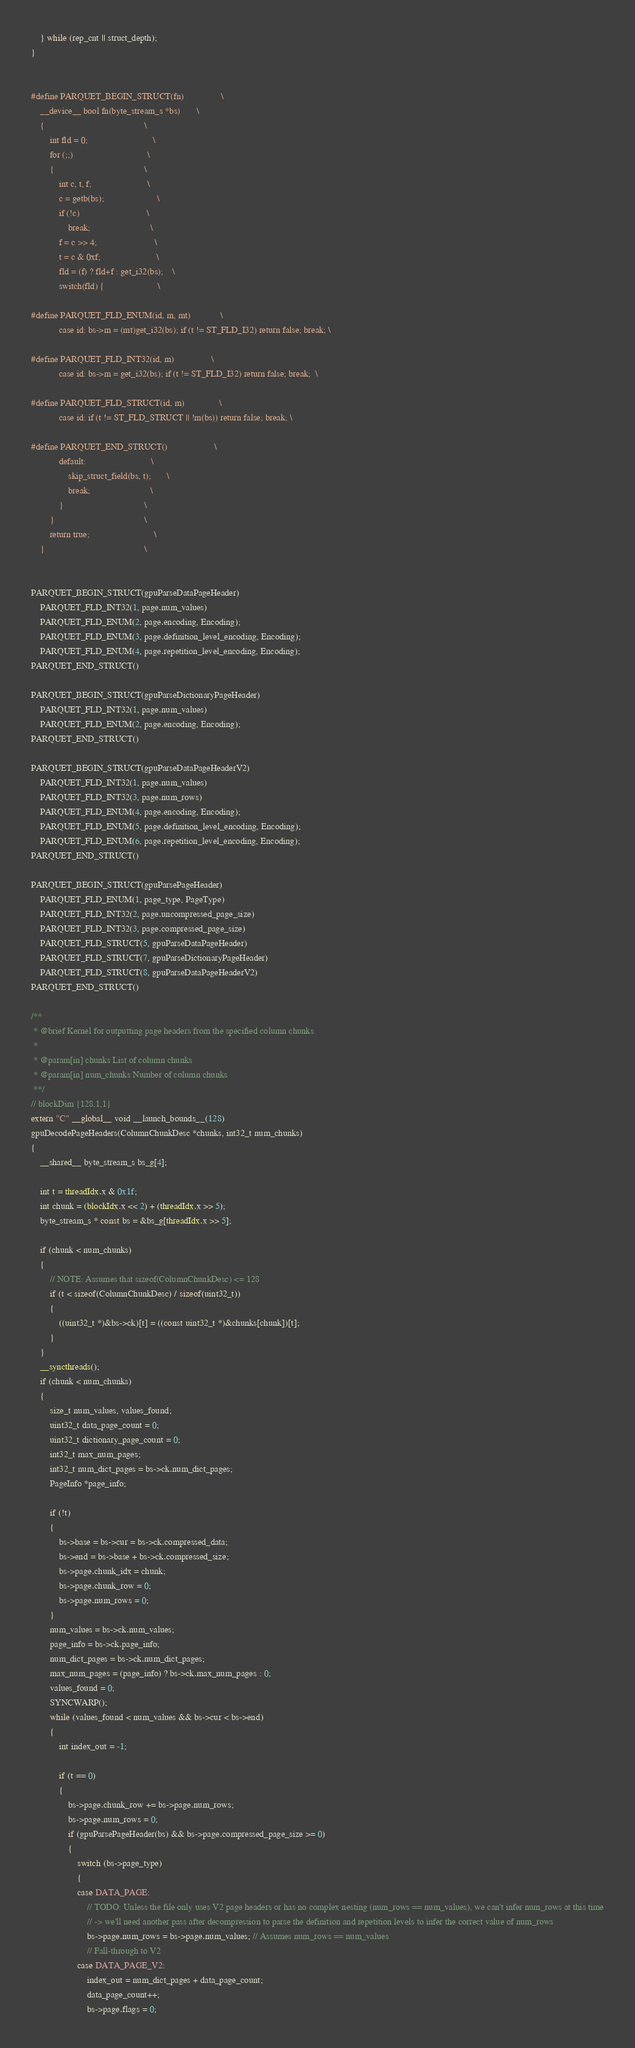<code> <loc_0><loc_0><loc_500><loc_500><_Cuda_>    } while (rep_cnt || struct_depth);
}


#define PARQUET_BEGIN_STRUCT(fn)                \
    __device__ bool fn(byte_stream_s *bs)       \
    {                                           \
        int fld = 0;                            \
        for (;;)                                \
        {                                       \
            int c, t, f;                        \
            c = getb(bs);                       \
            if (!c)                             \
                break;                          \
            f = c >> 4;                         \
            t = c & 0xf;                        \
            fld = (f) ? fld+f : get_i32(bs);    \
            switch(fld) {                       \

#define PARQUET_FLD_ENUM(id, m, mt)             \
            case id: bs->m = (mt)get_i32(bs); if (t != ST_FLD_I32) return false; break; \

#define PARQUET_FLD_INT32(id, m)                \
            case id: bs->m = get_i32(bs); if (t != ST_FLD_I32) return false; break;  \

#define PARQUET_FLD_STRUCT(id, m)               \
            case id: if (t != ST_FLD_STRUCT || !m(bs)) return false; break; \

#define PARQUET_END_STRUCT()                    \
            default:                            \
                skip_struct_field(bs, t);       \
                break;                          \
            }                                   \
        }                                       \
        return true;                            \
    }                                           \


PARQUET_BEGIN_STRUCT(gpuParseDataPageHeader)
    PARQUET_FLD_INT32(1, page.num_values)
    PARQUET_FLD_ENUM(2, page.encoding, Encoding);
    PARQUET_FLD_ENUM(3, page.definition_level_encoding, Encoding);
    PARQUET_FLD_ENUM(4, page.repetition_level_encoding, Encoding);
PARQUET_END_STRUCT()

PARQUET_BEGIN_STRUCT(gpuParseDictionaryPageHeader)
    PARQUET_FLD_INT32(1, page.num_values)
    PARQUET_FLD_ENUM(2, page.encoding, Encoding);
PARQUET_END_STRUCT()

PARQUET_BEGIN_STRUCT(gpuParseDataPageHeaderV2)
    PARQUET_FLD_INT32(1, page.num_values)
    PARQUET_FLD_INT32(3, page.num_rows)
    PARQUET_FLD_ENUM(4, page.encoding, Encoding);
    PARQUET_FLD_ENUM(5, page.definition_level_encoding, Encoding);
    PARQUET_FLD_ENUM(6, page.repetition_level_encoding, Encoding);
PARQUET_END_STRUCT()

PARQUET_BEGIN_STRUCT(gpuParsePageHeader)
    PARQUET_FLD_ENUM(1, page_type, PageType)
    PARQUET_FLD_INT32(2, page.uncompressed_page_size)
    PARQUET_FLD_INT32(3, page.compressed_page_size)
    PARQUET_FLD_STRUCT(5, gpuParseDataPageHeader)
    PARQUET_FLD_STRUCT(7, gpuParseDictionaryPageHeader)
    PARQUET_FLD_STRUCT(8, gpuParseDataPageHeaderV2)
PARQUET_END_STRUCT()

/**
 * @brief Kernel for outputting page headers from the specified column chunks
 *
 * @param[in] chunks List of column chunks
 * @param[in] num_chunks Number of column chunks
 **/
// blockDim {128,1,1}
extern "C" __global__ void __launch_bounds__(128)
gpuDecodePageHeaders(ColumnChunkDesc *chunks, int32_t num_chunks)
{
    __shared__ byte_stream_s bs_g[4];

    int t = threadIdx.x & 0x1f;
    int chunk = (blockIdx.x << 2) + (threadIdx.x >> 5);
    byte_stream_s * const bs = &bs_g[threadIdx.x >> 5];

    if (chunk < num_chunks)
    {
        // NOTE: Assumes that sizeof(ColumnChunkDesc) <= 128
        if (t < sizeof(ColumnChunkDesc) / sizeof(uint32_t))
        {
            ((uint32_t *)&bs->ck)[t] = ((const uint32_t *)&chunks[chunk])[t];
        }
    }
    __syncthreads();
    if (chunk < num_chunks)
    {
        size_t num_values, values_found;
        uint32_t data_page_count = 0;
        uint32_t dictionary_page_count = 0;
        int32_t max_num_pages;
        int32_t num_dict_pages = bs->ck.num_dict_pages;
        PageInfo *page_info;

        if (!t)
        {
            bs->base = bs->cur = bs->ck.compressed_data;
            bs->end = bs->base + bs->ck.compressed_size;
            bs->page.chunk_idx = chunk;
            bs->page.chunk_row = 0;
            bs->page.num_rows = 0;
        }
        num_values = bs->ck.num_values;
        page_info = bs->ck.page_info;
        num_dict_pages = bs->ck.num_dict_pages;
        max_num_pages = (page_info) ? bs->ck.max_num_pages : 0;
        values_found = 0;
        SYNCWARP();
        while (values_found < num_values && bs->cur < bs->end)
        {
            int index_out = -1;

            if (t == 0)
            {
                bs->page.chunk_row += bs->page.num_rows;
                bs->page.num_rows = 0;
                if (gpuParsePageHeader(bs) && bs->page.compressed_page_size >= 0)
                {
                    switch (bs->page_type)
                    {
                    case DATA_PAGE:
                        // TODO: Unless the file only uses V2 page headers or has no complex nesting (num_rows == num_values), we can't infer num_rows at this time
                        // -> we'll need another pass after decompression to parse the definition and repetition levels to infer the correct value of num_rows
                        bs->page.num_rows = bs->page.num_values; // Assumes num_rows == num_values
                        // Fall-through to V2
                    case DATA_PAGE_V2:
                        index_out = num_dict_pages + data_page_count;
                        data_page_count++;
                        bs->page.flags = 0;</code> 